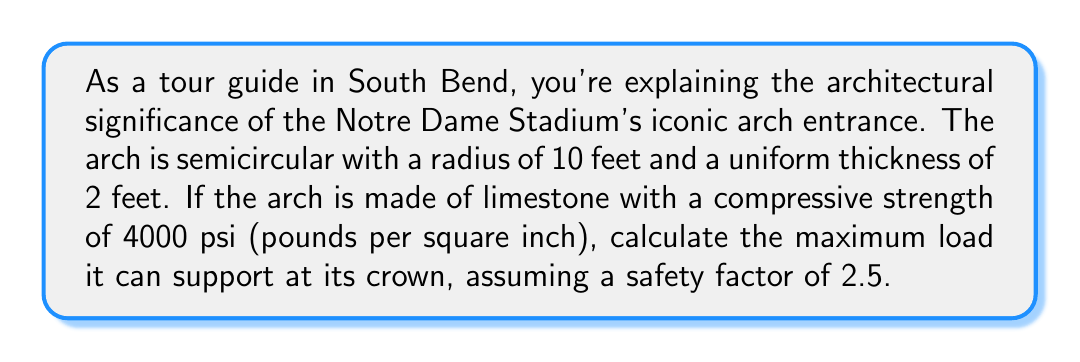Can you solve this math problem? Let's approach this step-by-step:

1) First, we need to calculate the cross-sectional area of the arch at its crown:
   Area = thickness × width
   Assuming a unit width of 1 foot:
   $A = 2 \text{ ft} \times 1 \text{ ft} = 2 \text{ ft}^2 = 288 \text{ in}^2$

2) The compressive strength of limestone is given as 4000 psi. With a safety factor of 2.5, the allowable stress is:
   $\sigma_{\text{allowable}} = \frac{4000 \text{ psi}}{2.5} = 1600 \text{ psi}$

3) The maximum force the arch can support is:
   $F_{\text{max}} = \sigma_{\text{allowable}} \times A = 1600 \text{ psi} \times 288 \text{ in}^2 = 460,800 \text{ lbs}$

4) However, this is not the actual load-bearing capacity at the crown. In a semicircular arch, the horizontal thrust at the crown is related to the vertical load by:
   $H = \frac{WR}{2h}$
   Where $H$ is the horizontal thrust, $W$ is the vertical load, $R$ is the radius, and $h$ is the rise (which equals $R$ for a semicircular arch).

5) The resultant force at the crown is:
   $F_{\text{resultant}} = \sqrt{W^2 + H^2} = \sqrt{W^2 + (\frac{WR}{2R})^2} = \sqrt{W^2 + (\frac{W}{2})^2} = W\sqrt{\frac{5}{4}}$

6) Setting this equal to our maximum force:
   $W\sqrt{\frac{5}{4}} = 460,800 \text{ lbs}$

7) Solving for $W$:
   $W = \frac{460,800}{\sqrt{\frac{5}{4}}} = 411,744 \text{ lbs}$

Therefore, the maximum load the arch can support at its crown is approximately 411,744 lbs or 205.87 tons.
Answer: 411,744 lbs 